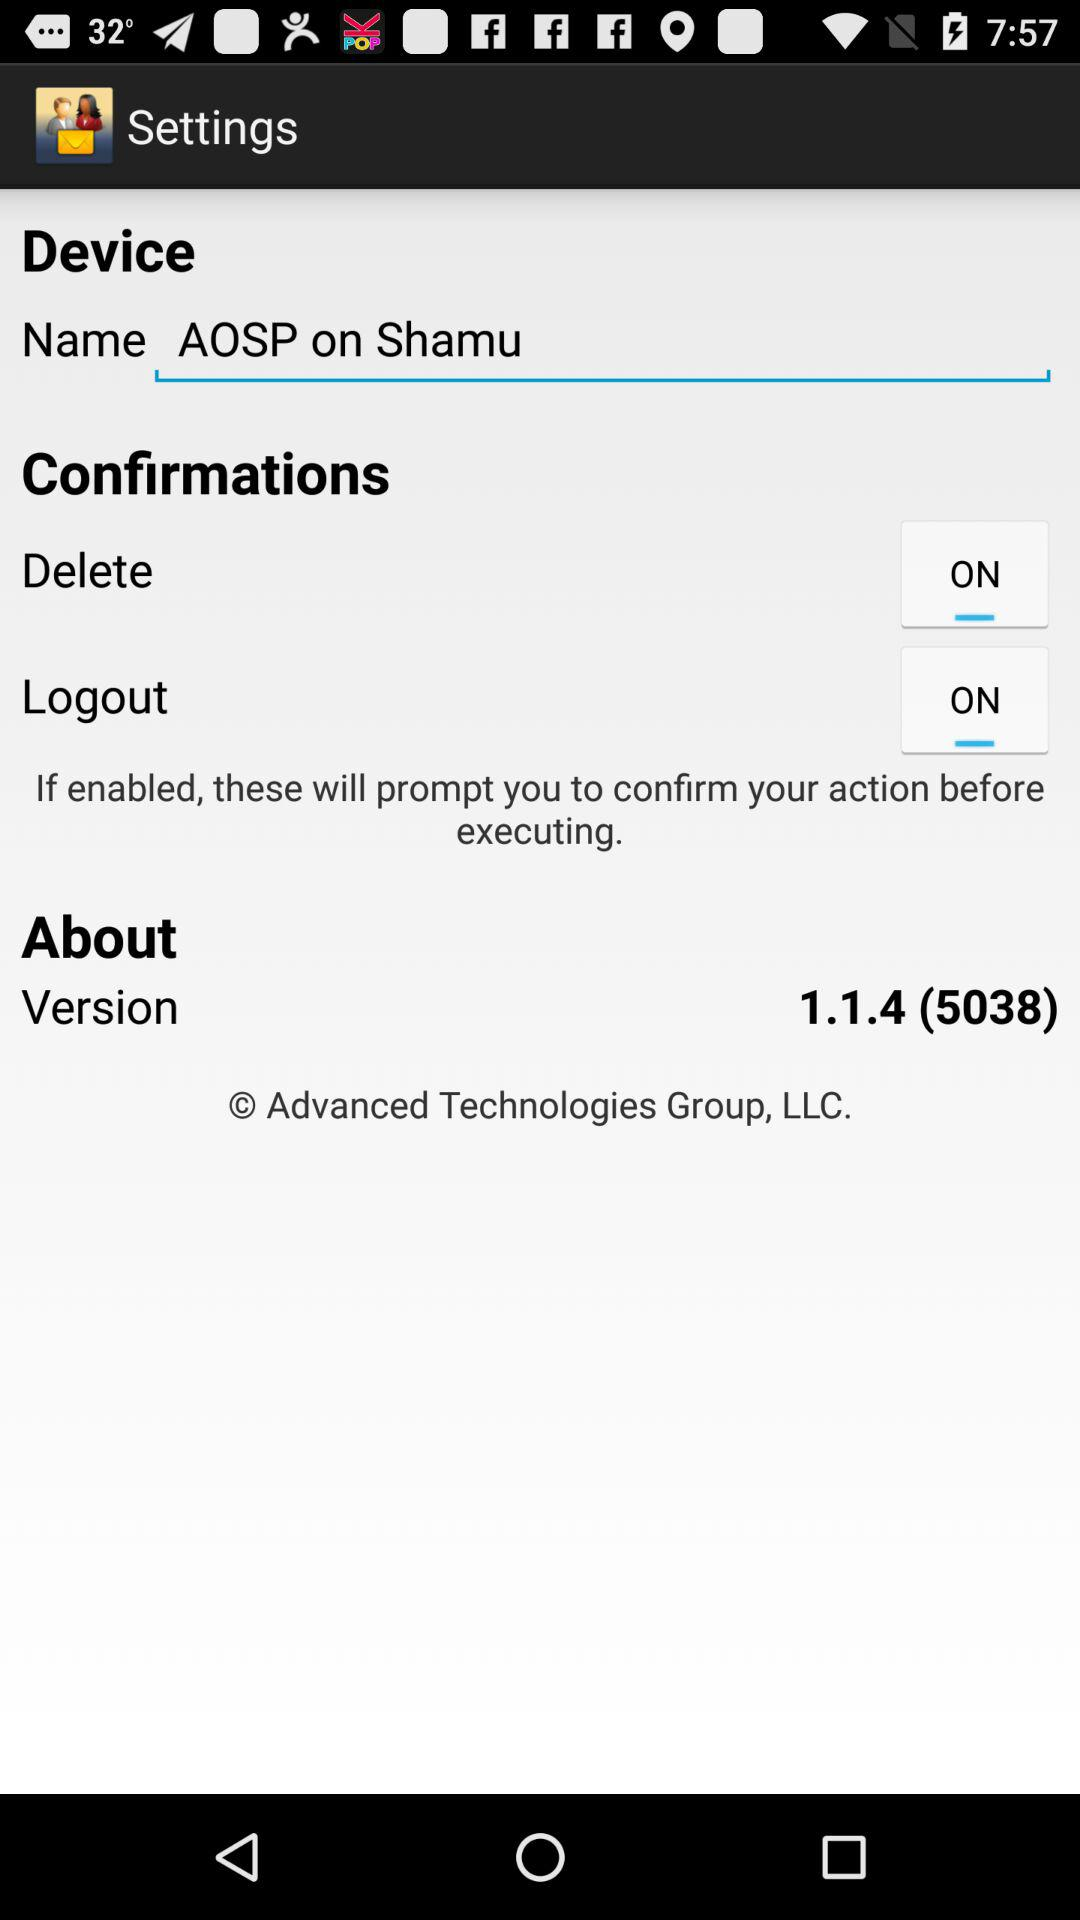How many confirmations are available?
Answer the question using a single word or phrase. 2 